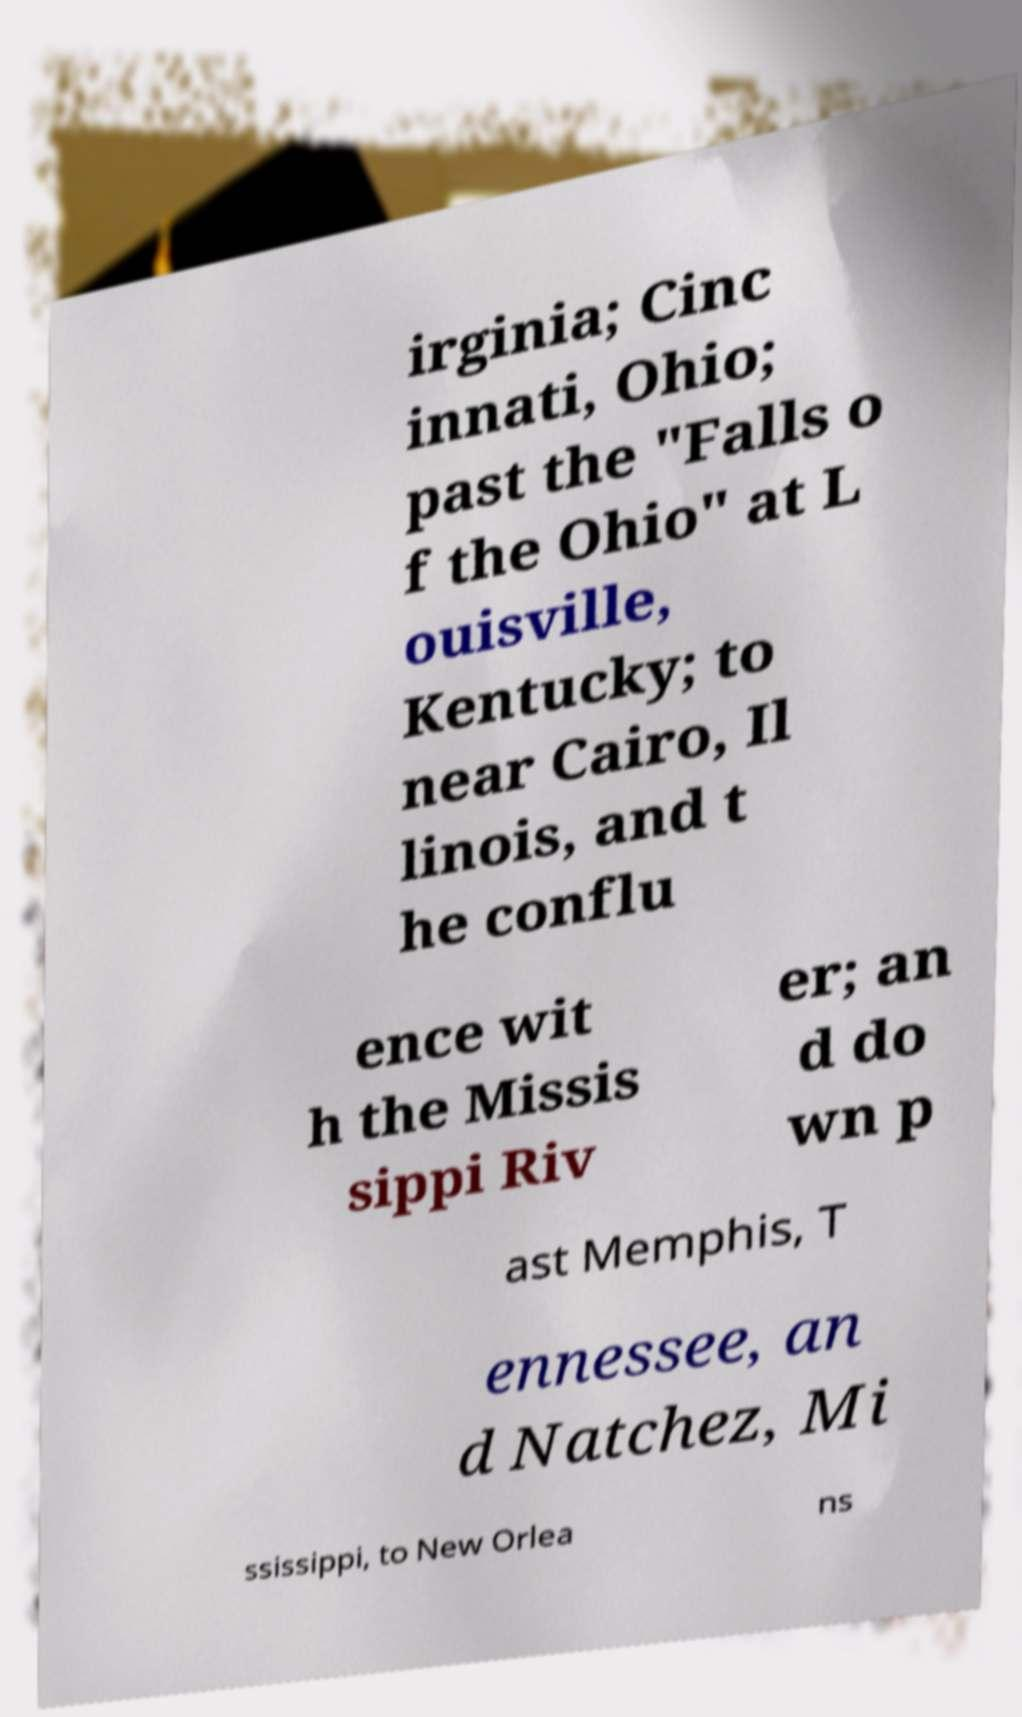Could you assist in decoding the text presented in this image and type it out clearly? irginia; Cinc innati, Ohio; past the "Falls o f the Ohio" at L ouisville, Kentucky; to near Cairo, Il linois, and t he conflu ence wit h the Missis sippi Riv er; an d do wn p ast Memphis, T ennessee, an d Natchez, Mi ssissippi, to New Orlea ns 